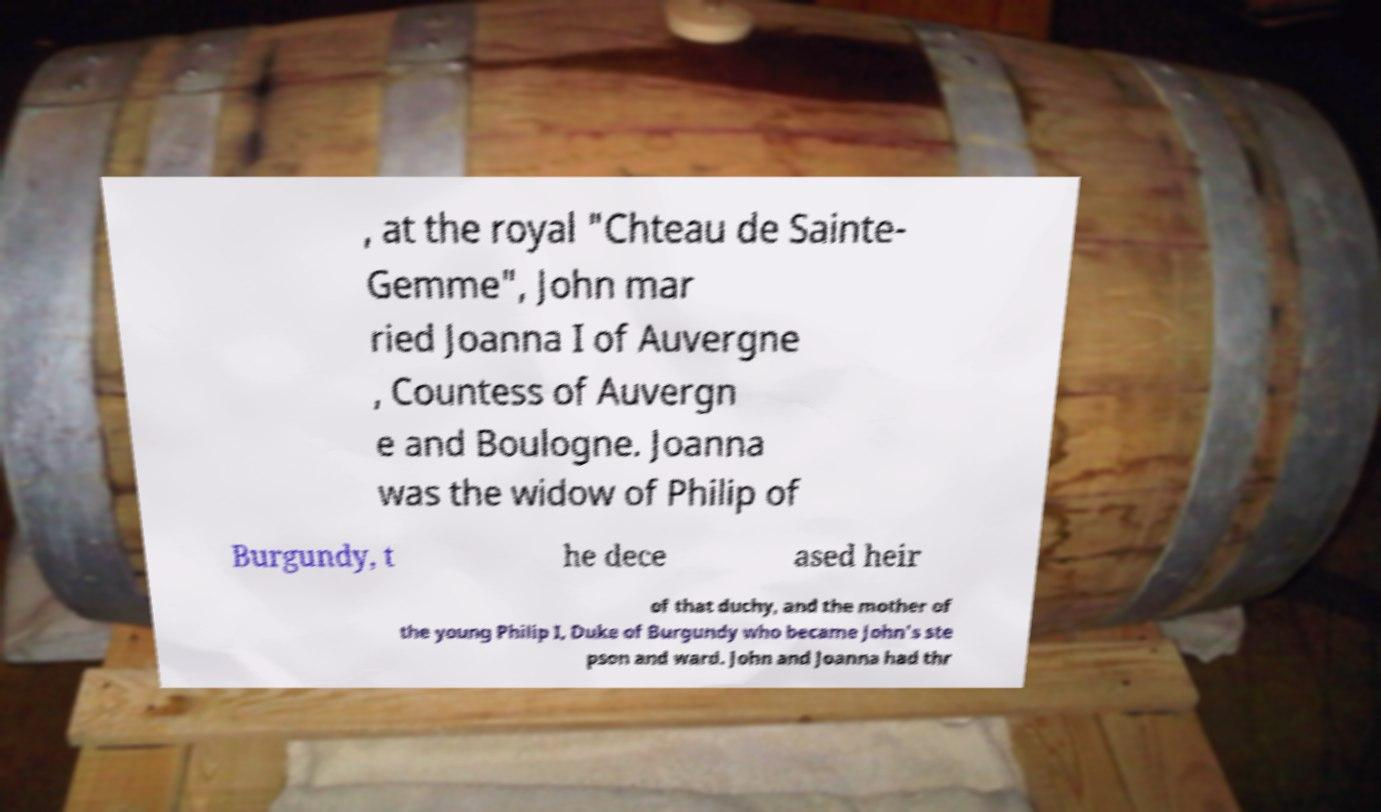Could you assist in decoding the text presented in this image and type it out clearly? , at the royal "Chteau de Sainte- Gemme", John mar ried Joanna I of Auvergne , Countess of Auvergn e and Boulogne. Joanna was the widow of Philip of Burgundy, t he dece ased heir of that duchy, and the mother of the young Philip I, Duke of Burgundy who became John's ste pson and ward. John and Joanna had thr 